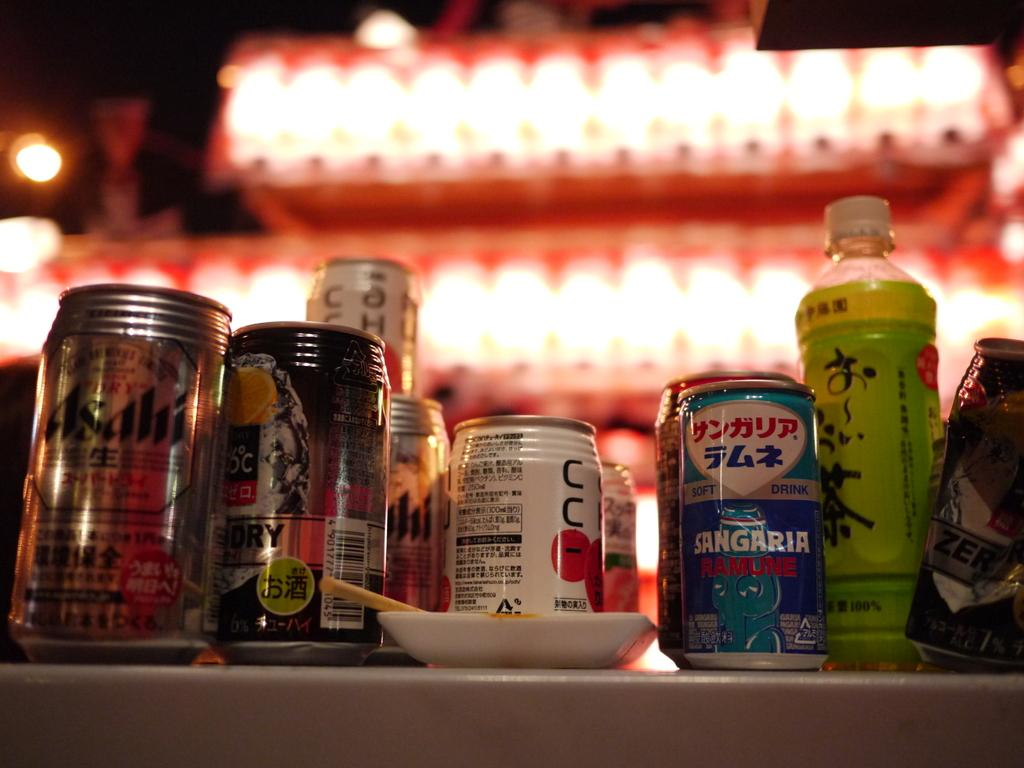<image>
Summarize the visual content of the image. Various japanese drinks including ashi and sangraria ramune. 